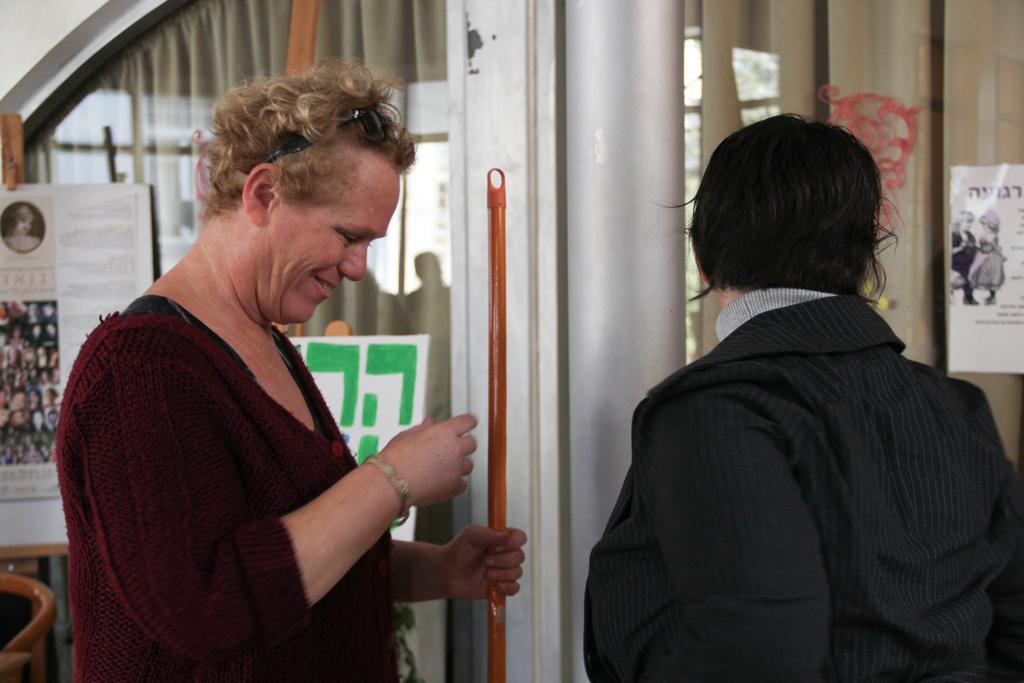Please provide a concise description of this image. In this image we can see two persons, one of them is holding a stick, there are posters on the mirrors with some text on them, there are curtains, also we can see the wall. 